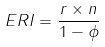Convert formula to latex. <formula><loc_0><loc_0><loc_500><loc_500>E R I = \frac { r \times n } { 1 - \phi }</formula> 